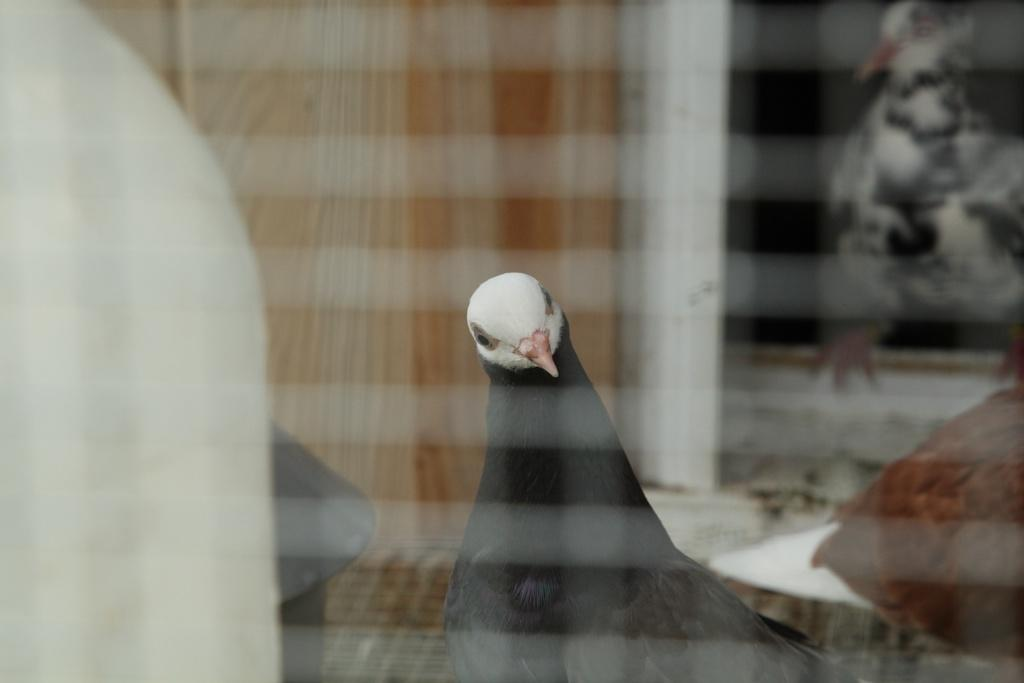What object is present in the picture that can hold a liquid? There is a glass in the picture. What can be seen through the glass? A bird is visible through the glass. Can you describe the appearance of the bird? The bird is black in color with a white face and beak. What is present in the image that can provide privacy or block light? There is a curtain in the image. What architectural feature is visible in the image? There is a window frame in the image. What type of paste is being used to play an instrument in the image? There is no paste or instrument present in the image; it features a glass with a bird visible through it, a curtain, and a window frame. 